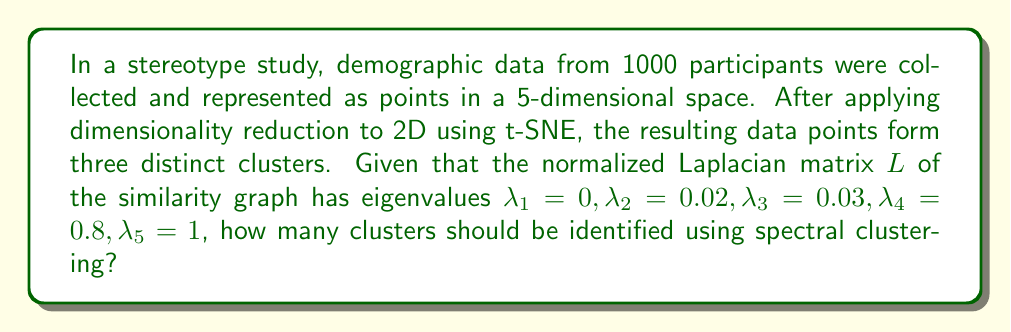Can you answer this question? To determine the number of clusters using spectral clustering, we follow these steps:

1. Examine the eigenvalues of the normalized Laplacian matrix $L$:
   $\lambda_1 = 0, \lambda_2 = 0.02, \lambda_3 = 0.03, \lambda_4 = 0.8, \lambda_5 = 1$

2. Look for a significant gap in the eigenvalues. The number of clusters is typically determined by the number of eigenvalues before this gap.

3. Calculate the differences between consecutive eigenvalues:
   $\lambda_2 - \lambda_1 = 0.02$
   $\lambda_3 - \lambda_2 = 0.01$
   $\lambda_4 - \lambda_3 = 0.77$
   $\lambda_5 - \lambda_4 = 0.2$

4. The largest gap is between $\lambda_3$ and $\lambda_4$ (0.77).

5. Count the number of eigenvalues before this gap: 3 (including $\lambda_1, \lambda_2, \lambda_3$).

Therefore, spectral clustering suggests 3 clusters in the data, which aligns with the visual observation of three distinct clusters after t-SNE dimensionality reduction.
Answer: 3 clusters 